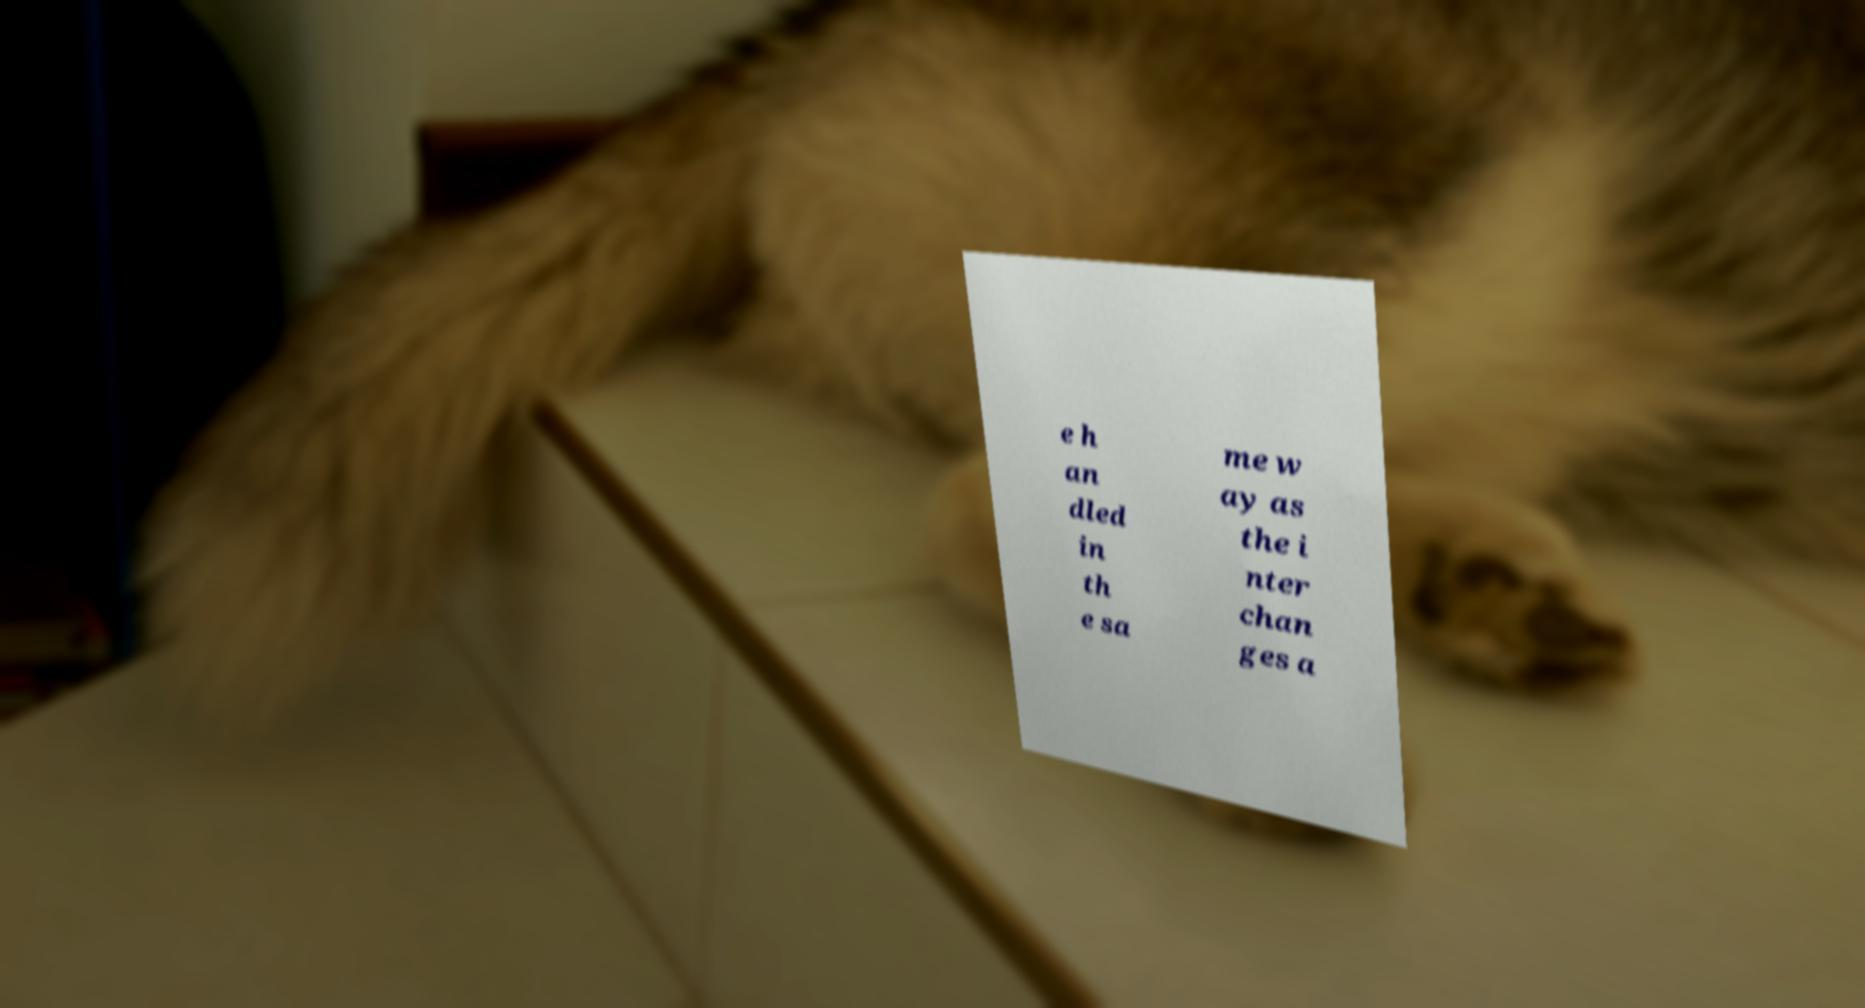What messages or text are displayed in this image? I need them in a readable, typed format. e h an dled in th e sa me w ay as the i nter chan ges a 